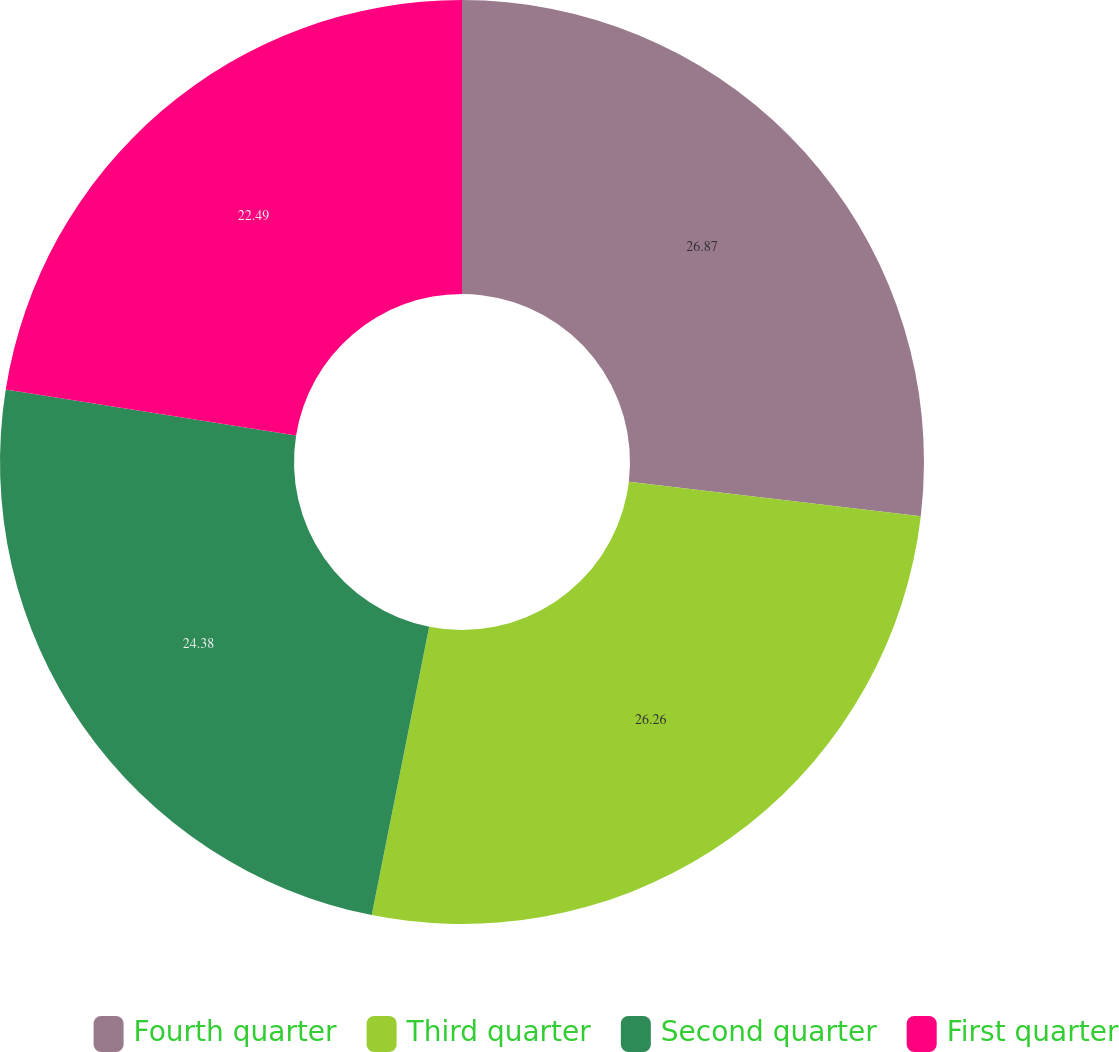<chart> <loc_0><loc_0><loc_500><loc_500><pie_chart><fcel>Fourth quarter<fcel>Third quarter<fcel>Second quarter<fcel>First quarter<nl><fcel>26.87%<fcel>26.26%<fcel>24.38%<fcel>22.49%<nl></chart> 